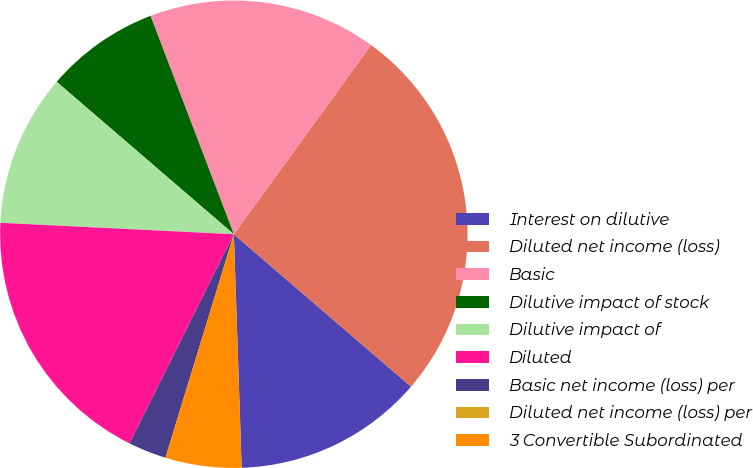Convert chart. <chart><loc_0><loc_0><loc_500><loc_500><pie_chart><fcel>Interest on dilutive<fcel>Diluted net income (loss)<fcel>Basic<fcel>Dilutive impact of stock<fcel>Dilutive impact of<fcel>Diluted<fcel>Basic net income (loss) per<fcel>Diluted net income (loss) per<fcel>3 Convertible Subordinated<nl><fcel>13.16%<fcel>26.32%<fcel>15.79%<fcel>7.89%<fcel>10.53%<fcel>18.42%<fcel>2.63%<fcel>0.0%<fcel>5.26%<nl></chart> 